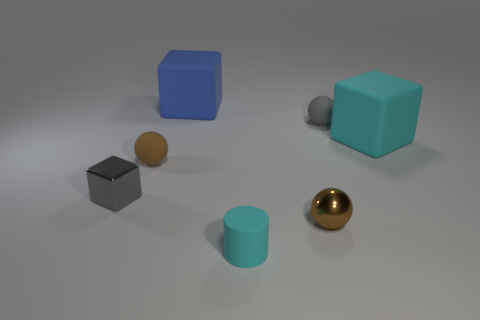Subtract all red blocks. How many brown spheres are left? 2 Subtract all gray balls. How many balls are left? 2 Add 1 small brown matte objects. How many objects exist? 8 Subtract all balls. How many objects are left? 4 Add 2 brown spheres. How many brown spheres are left? 4 Add 3 blue matte spheres. How many blue matte spheres exist? 3 Subtract 0 cyan spheres. How many objects are left? 7 Subtract all matte cubes. Subtract all brown objects. How many objects are left? 3 